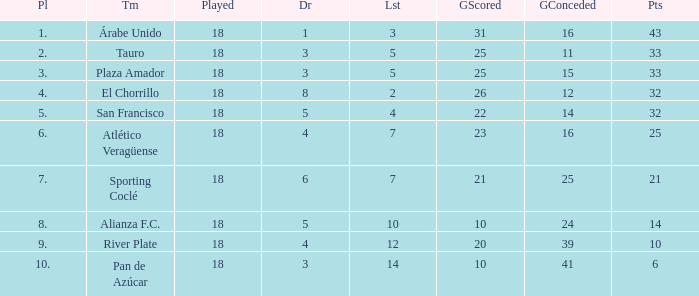How many goals were conceded by the team with more than 21 points more than 5 draws and less than 18 games played? None. Can you give me this table as a dict? {'header': ['Pl', 'Tm', 'Played', 'Dr', 'Lst', 'GScored', 'GConceded', 'Pts'], 'rows': [['1.', 'Árabe Unido', '18', '1', '3', '31', '16', '43'], ['2.', 'Tauro', '18', '3', '5', '25', '11', '33'], ['3.', 'Plaza Amador', '18', '3', '5', '25', '15', '33'], ['4.', 'El Chorrillo', '18', '8', '2', '26', '12', '32'], ['5.', 'San Francisco', '18', '5', '4', '22', '14', '32'], ['6.', 'Atlético Veragüense', '18', '4', '7', '23', '16', '25'], ['7.', 'Sporting Coclé', '18', '6', '7', '21', '25', '21'], ['8.', 'Alianza F.C.', '18', '5', '10', '10', '24', '14'], ['9.', 'River Plate', '18', '4', '12', '20', '39', '10'], ['10.', 'Pan de Azúcar', '18', '3', '14', '10', '41', '6']]} 